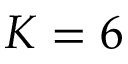Convert formula to latex. <formula><loc_0><loc_0><loc_500><loc_500>K = 6</formula> 